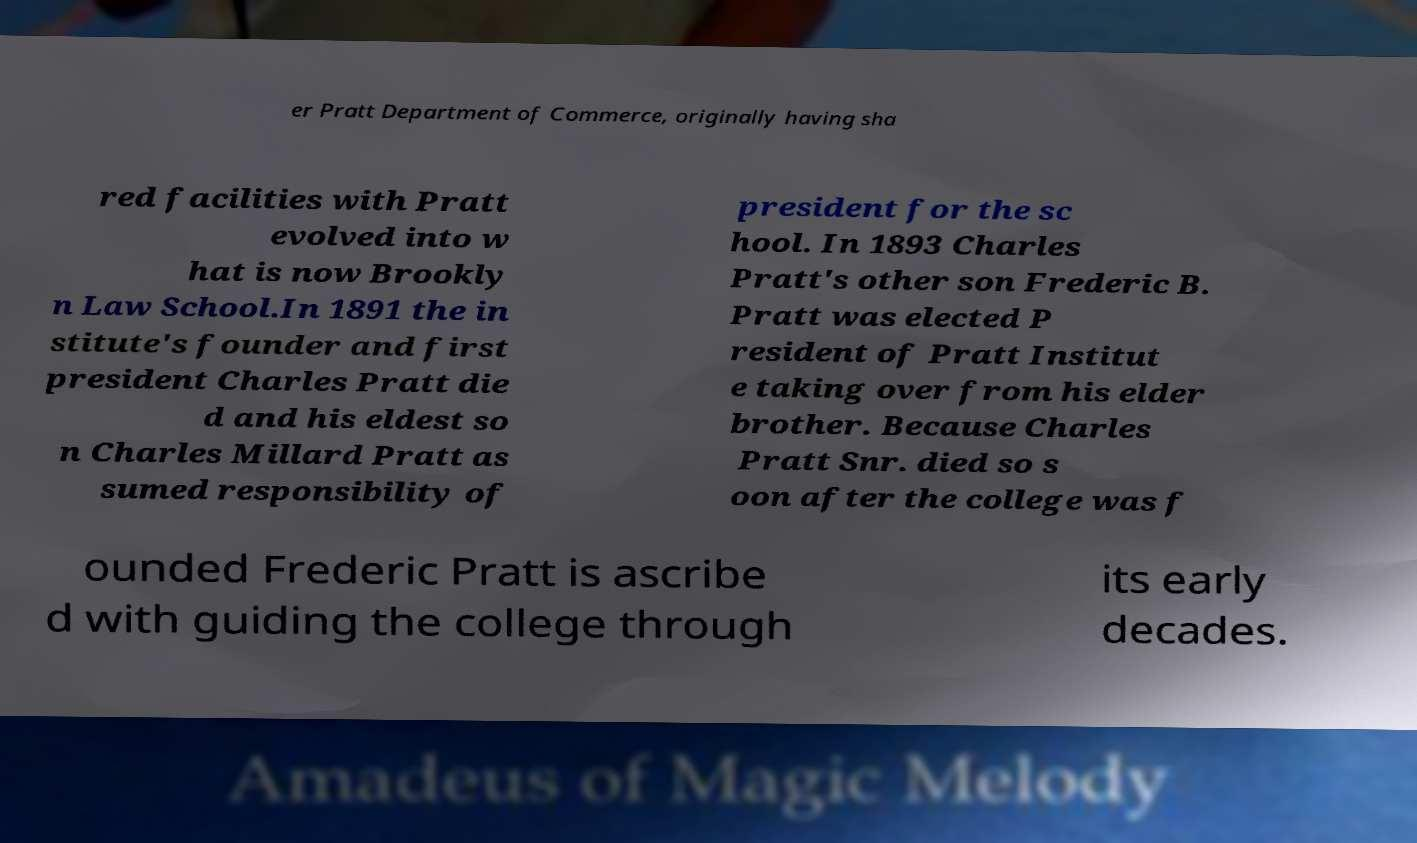Can you accurately transcribe the text from the provided image for me? er Pratt Department of Commerce, originally having sha red facilities with Pratt evolved into w hat is now Brookly n Law School.In 1891 the in stitute's founder and first president Charles Pratt die d and his eldest so n Charles Millard Pratt as sumed responsibility of president for the sc hool. In 1893 Charles Pratt's other son Frederic B. Pratt was elected P resident of Pratt Institut e taking over from his elder brother. Because Charles Pratt Snr. died so s oon after the college was f ounded Frederic Pratt is ascribe d with guiding the college through its early decades. 